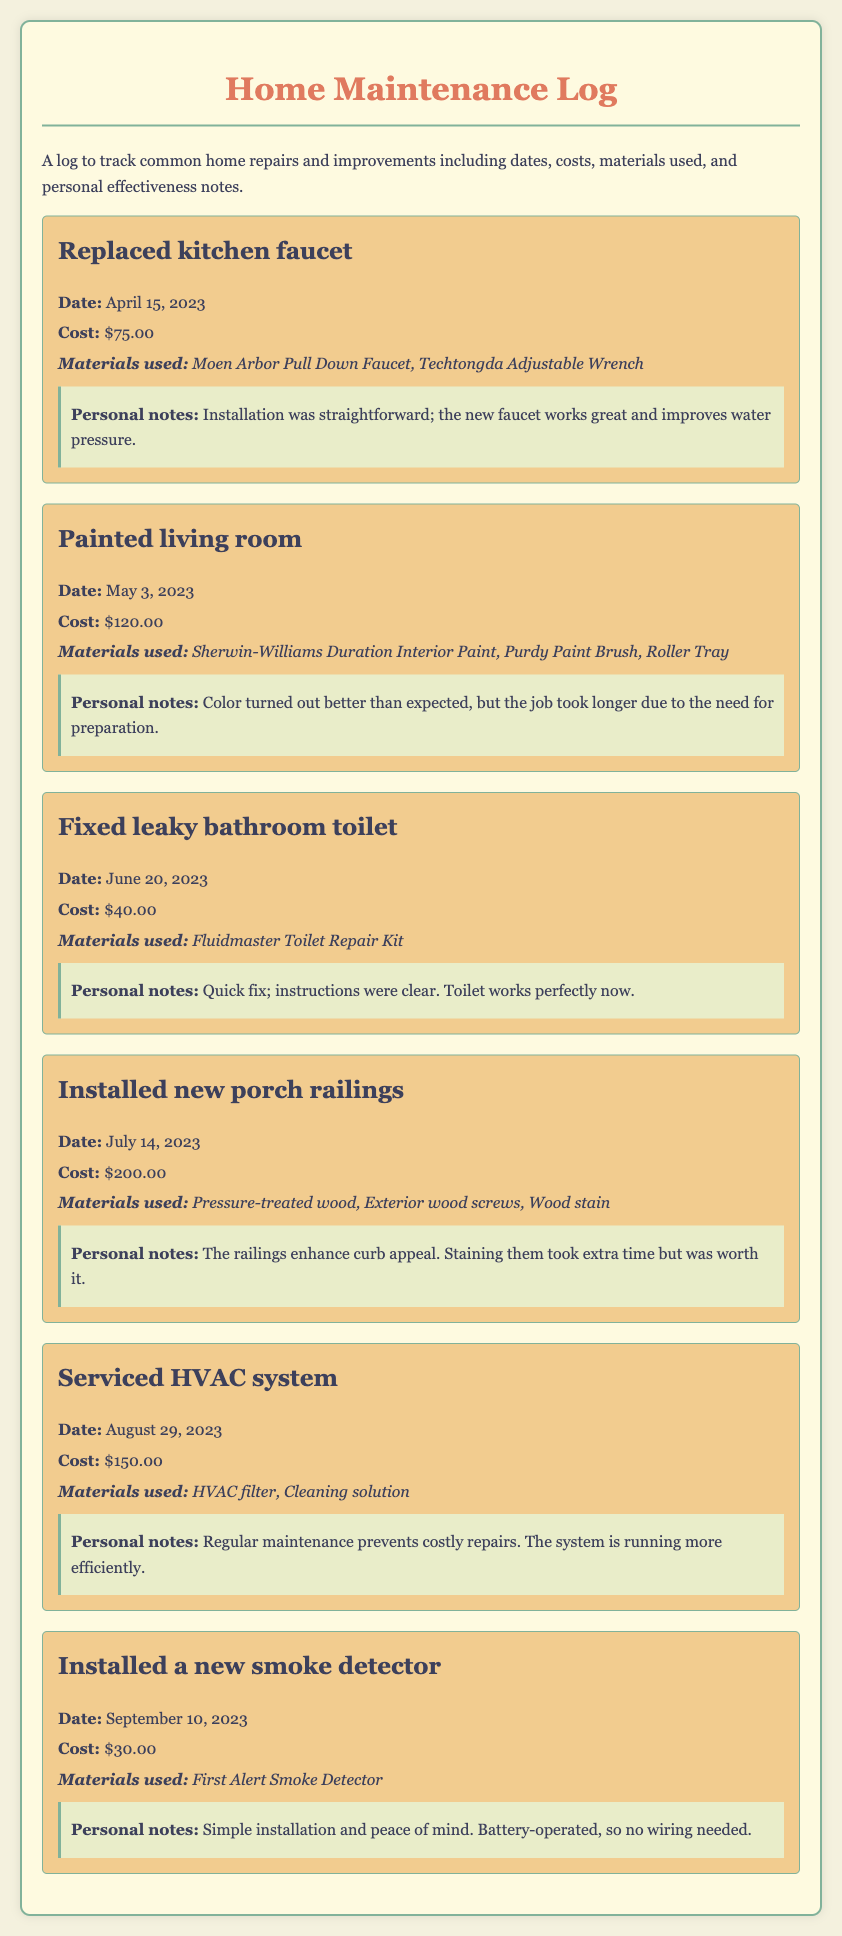what was the cost of installing a new smoke detector? The cost listed for the new smoke detector installation is stated in the document as $30.00.
Answer: $30.00 when was the kitchen faucet replaced? The date for the kitchen faucet replacement is provided in the entry as April 15, 2023.
Answer: April 15, 2023 what materials were used to paint the living room? The materials mentioned for painting the living room are specified as Sherwin-Williams Duration Interior Paint, Purdy Paint Brush, Roller Tray.
Answer: Sherwin-Williams Duration Interior Paint, Purdy Paint Brush, Roller Tray how much did it cost to service the HVAC system? The cost associated with servicing the HVAC system is given as $150.00.
Answer: $150.00 what personal note was made about the porch railings? The note indicates that the railings enhance curb appeal and mentions that staining took extra time but was worth it.
Answer: Enhance curb appeal; worth it how does the personal note on the HVAC system indicate its effectiveness? The note reveals that regular maintenance prevents costly repairs and states that the system is running more efficiently.
Answer: Running more efficiently what was the total cost for fixing the leaky bathroom toilet and installing the new smoke detector? The total is calculated as the sum of the cost for fixing the leaky toilet ($40.00) and the smoke detector ($30.00), which is $70.00.
Answer: $70.00 what type of log is this document classified as? The document is classified as a Home Maintenance Log.
Answer: Home Maintenance Log what is the purpose of this home maintenance log? The purpose stated in the document is to track common home repairs and improvements, including dates, costs, materials used, and personal notes.
Answer: Track common home repairs and improvements 